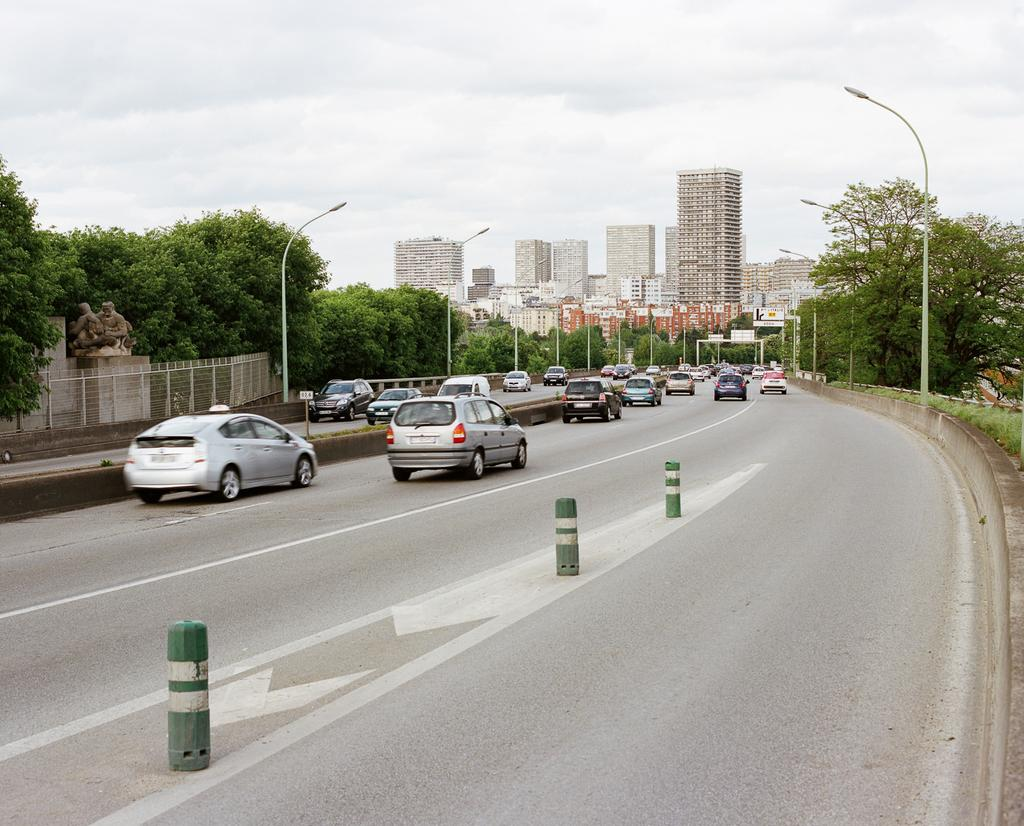What type of structures can be seen in the image? There are buildings in the image. What other natural elements are present in the image? There are trees in the image. What type of lighting is present in the image? There are pole lights in the image. What type of transportation can be seen in the image? There are cars moving on the road in the image. What is located on the left side of the image? There is a metal fence on the left side of the image. What is the condition of the sky in the image? The sky is cloudy in the image. What type of science experiment is being conducted with frogs in the image? There is no frogs present in the image, and there is no indication of a science experiment taking place. 